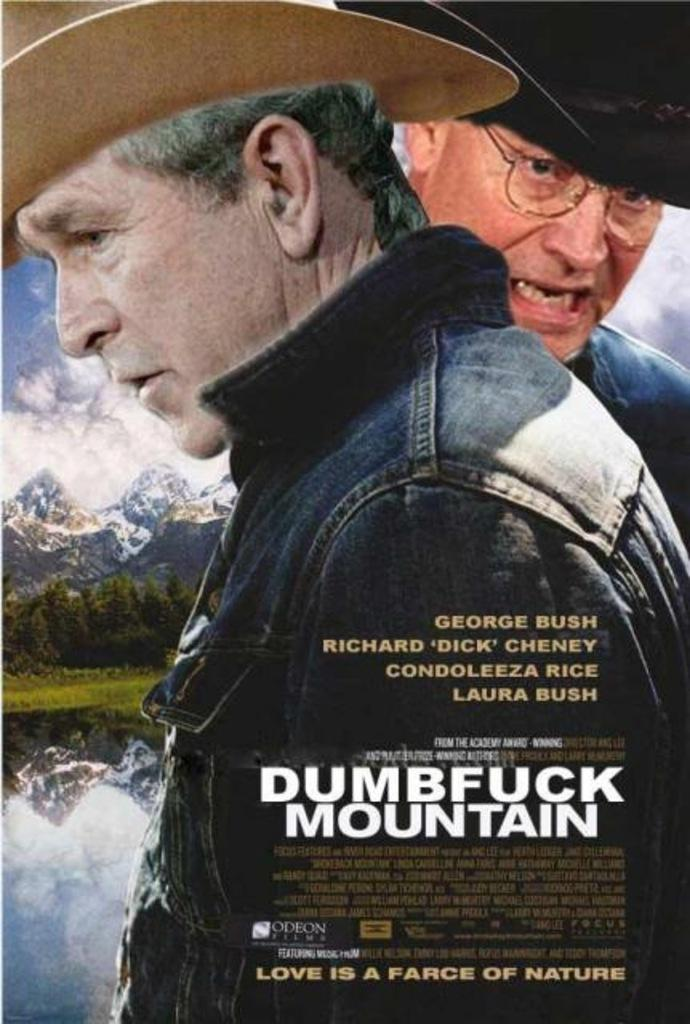What is the main feature of the image? There is a banner in the image. What is depicted on the banner? The banner shows two people wearing black color jackets, water, hills, and the sky. What is written on the banner? There is some matter written on the banner. What type of boundary can be seen in the image? There is no boundary present in the image; it features a banner with various elements depicted on it. How does the rainstorm affect the people on the banner? There is no rainstorm depicted on the banner; it shows people wearing jackets, water, hills, and the sky. 